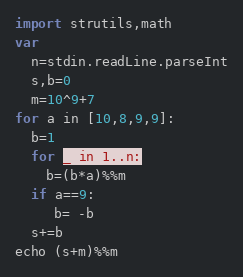Convert code to text. <code><loc_0><loc_0><loc_500><loc_500><_Nim_>import strutils,math
var
  n=stdin.readLine.parseInt
  s,b=0
  m=10^9+7
for a in [10,8,9,9]:
  b=1
  for _ in 1..n:
    b=(b*a)%%m
  if a==9:
     b= -b
  s+=b
echo (s+m)%%m</code> 